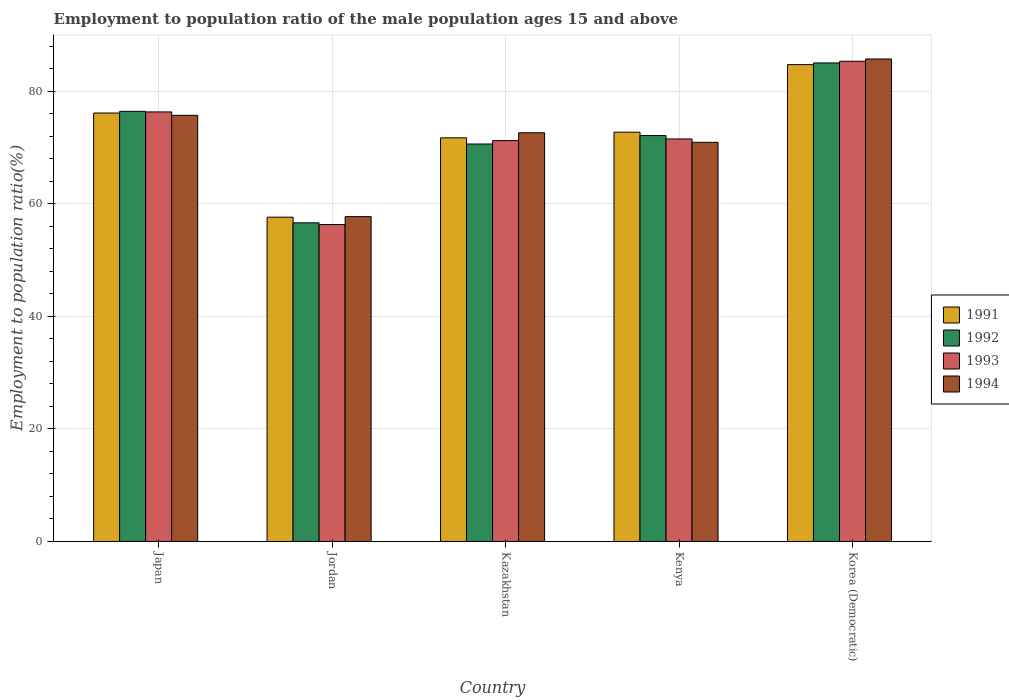How many different coloured bars are there?
Provide a short and direct response. 4. How many groups of bars are there?
Provide a short and direct response. 5. How many bars are there on the 2nd tick from the left?
Your response must be concise. 4. What is the label of the 5th group of bars from the left?
Ensure brevity in your answer.  Korea (Democratic). In how many cases, is the number of bars for a given country not equal to the number of legend labels?
Provide a short and direct response. 0. What is the employment to population ratio in 1994 in Kazakhstan?
Your response must be concise. 72.6. Across all countries, what is the maximum employment to population ratio in 1994?
Offer a terse response. 85.7. Across all countries, what is the minimum employment to population ratio in 1991?
Your answer should be compact. 57.6. In which country was the employment to population ratio in 1993 maximum?
Ensure brevity in your answer.  Korea (Democratic). In which country was the employment to population ratio in 1992 minimum?
Offer a terse response. Jordan. What is the total employment to population ratio in 1994 in the graph?
Provide a succinct answer. 362.6. What is the difference between the employment to population ratio in 1991 in Jordan and that in Kazakhstan?
Offer a very short reply. -14.1. What is the difference between the employment to population ratio in 1992 in Kenya and the employment to population ratio in 1993 in Jordan?
Offer a terse response. 15.8. What is the average employment to population ratio in 1994 per country?
Make the answer very short. 72.52. In how many countries, is the employment to population ratio in 1992 greater than 72 %?
Your answer should be compact. 3. What is the ratio of the employment to population ratio in 1994 in Kazakhstan to that in Korea (Democratic)?
Offer a terse response. 0.85. Is the difference between the employment to population ratio in 1994 in Jordan and Korea (Democratic) greater than the difference between the employment to population ratio in 1991 in Jordan and Korea (Democratic)?
Offer a very short reply. No. What is the difference between the highest and the second highest employment to population ratio in 1991?
Your answer should be very brief. -12. What is the difference between the highest and the lowest employment to population ratio in 1994?
Offer a very short reply. 28. In how many countries, is the employment to population ratio in 1993 greater than the average employment to population ratio in 1993 taken over all countries?
Ensure brevity in your answer.  2. Is it the case that in every country, the sum of the employment to population ratio in 1991 and employment to population ratio in 1993 is greater than the sum of employment to population ratio in 1994 and employment to population ratio in 1992?
Give a very brief answer. No. What does the 4th bar from the left in Japan represents?
Ensure brevity in your answer.  1994. What does the 4th bar from the right in Japan represents?
Give a very brief answer. 1991. Is it the case that in every country, the sum of the employment to population ratio in 1994 and employment to population ratio in 1993 is greater than the employment to population ratio in 1992?
Offer a terse response. Yes. How many bars are there?
Your response must be concise. 20. How many countries are there in the graph?
Offer a very short reply. 5. Are the values on the major ticks of Y-axis written in scientific E-notation?
Ensure brevity in your answer.  No. Does the graph contain any zero values?
Your answer should be compact. No. How many legend labels are there?
Offer a very short reply. 4. How are the legend labels stacked?
Provide a short and direct response. Vertical. What is the title of the graph?
Make the answer very short. Employment to population ratio of the male population ages 15 and above. Does "2004" appear as one of the legend labels in the graph?
Offer a very short reply. No. What is the label or title of the X-axis?
Provide a short and direct response. Country. What is the Employment to population ratio(%) in 1991 in Japan?
Provide a succinct answer. 76.1. What is the Employment to population ratio(%) in 1992 in Japan?
Give a very brief answer. 76.4. What is the Employment to population ratio(%) of 1993 in Japan?
Offer a terse response. 76.3. What is the Employment to population ratio(%) in 1994 in Japan?
Your answer should be very brief. 75.7. What is the Employment to population ratio(%) of 1991 in Jordan?
Your answer should be very brief. 57.6. What is the Employment to population ratio(%) of 1992 in Jordan?
Provide a short and direct response. 56.6. What is the Employment to population ratio(%) of 1993 in Jordan?
Your answer should be compact. 56.3. What is the Employment to population ratio(%) of 1994 in Jordan?
Offer a very short reply. 57.7. What is the Employment to population ratio(%) of 1991 in Kazakhstan?
Provide a succinct answer. 71.7. What is the Employment to population ratio(%) in 1992 in Kazakhstan?
Offer a terse response. 70.6. What is the Employment to population ratio(%) of 1993 in Kazakhstan?
Provide a succinct answer. 71.2. What is the Employment to population ratio(%) of 1994 in Kazakhstan?
Your response must be concise. 72.6. What is the Employment to population ratio(%) in 1991 in Kenya?
Keep it short and to the point. 72.7. What is the Employment to population ratio(%) of 1992 in Kenya?
Your answer should be very brief. 72.1. What is the Employment to population ratio(%) in 1993 in Kenya?
Provide a short and direct response. 71.5. What is the Employment to population ratio(%) in 1994 in Kenya?
Your response must be concise. 70.9. What is the Employment to population ratio(%) of 1991 in Korea (Democratic)?
Provide a succinct answer. 84.7. What is the Employment to population ratio(%) in 1993 in Korea (Democratic)?
Offer a very short reply. 85.3. What is the Employment to population ratio(%) in 1994 in Korea (Democratic)?
Provide a succinct answer. 85.7. Across all countries, what is the maximum Employment to population ratio(%) in 1991?
Make the answer very short. 84.7. Across all countries, what is the maximum Employment to population ratio(%) in 1993?
Provide a short and direct response. 85.3. Across all countries, what is the maximum Employment to population ratio(%) in 1994?
Provide a succinct answer. 85.7. Across all countries, what is the minimum Employment to population ratio(%) of 1991?
Make the answer very short. 57.6. Across all countries, what is the minimum Employment to population ratio(%) in 1992?
Keep it short and to the point. 56.6. Across all countries, what is the minimum Employment to population ratio(%) in 1993?
Your response must be concise. 56.3. Across all countries, what is the minimum Employment to population ratio(%) of 1994?
Ensure brevity in your answer.  57.7. What is the total Employment to population ratio(%) in 1991 in the graph?
Offer a very short reply. 362.8. What is the total Employment to population ratio(%) of 1992 in the graph?
Provide a short and direct response. 360.7. What is the total Employment to population ratio(%) in 1993 in the graph?
Keep it short and to the point. 360.6. What is the total Employment to population ratio(%) of 1994 in the graph?
Provide a short and direct response. 362.6. What is the difference between the Employment to population ratio(%) of 1992 in Japan and that in Jordan?
Make the answer very short. 19.8. What is the difference between the Employment to population ratio(%) of 1992 in Japan and that in Kazakhstan?
Your answer should be compact. 5.8. What is the difference between the Employment to population ratio(%) in 1991 in Japan and that in Kenya?
Your response must be concise. 3.4. What is the difference between the Employment to population ratio(%) of 1992 in Japan and that in Kenya?
Make the answer very short. 4.3. What is the difference between the Employment to population ratio(%) in 1993 in Japan and that in Kenya?
Make the answer very short. 4.8. What is the difference between the Employment to population ratio(%) of 1994 in Japan and that in Kenya?
Ensure brevity in your answer.  4.8. What is the difference between the Employment to population ratio(%) in 1993 in Japan and that in Korea (Democratic)?
Keep it short and to the point. -9. What is the difference between the Employment to population ratio(%) in 1991 in Jordan and that in Kazakhstan?
Keep it short and to the point. -14.1. What is the difference between the Employment to population ratio(%) in 1992 in Jordan and that in Kazakhstan?
Your answer should be very brief. -14. What is the difference between the Employment to population ratio(%) of 1993 in Jordan and that in Kazakhstan?
Offer a very short reply. -14.9. What is the difference between the Employment to population ratio(%) of 1994 in Jordan and that in Kazakhstan?
Your answer should be compact. -14.9. What is the difference between the Employment to population ratio(%) in 1991 in Jordan and that in Kenya?
Offer a terse response. -15.1. What is the difference between the Employment to population ratio(%) of 1992 in Jordan and that in Kenya?
Provide a succinct answer. -15.5. What is the difference between the Employment to population ratio(%) of 1993 in Jordan and that in Kenya?
Provide a short and direct response. -15.2. What is the difference between the Employment to population ratio(%) of 1991 in Jordan and that in Korea (Democratic)?
Provide a short and direct response. -27.1. What is the difference between the Employment to population ratio(%) in 1992 in Jordan and that in Korea (Democratic)?
Make the answer very short. -28.4. What is the difference between the Employment to population ratio(%) in 1993 in Jordan and that in Korea (Democratic)?
Your answer should be very brief. -29. What is the difference between the Employment to population ratio(%) in 1994 in Jordan and that in Korea (Democratic)?
Make the answer very short. -28. What is the difference between the Employment to population ratio(%) of 1991 in Kazakhstan and that in Kenya?
Ensure brevity in your answer.  -1. What is the difference between the Employment to population ratio(%) of 1993 in Kazakhstan and that in Kenya?
Your response must be concise. -0.3. What is the difference between the Employment to population ratio(%) of 1991 in Kazakhstan and that in Korea (Democratic)?
Your response must be concise. -13. What is the difference between the Employment to population ratio(%) of 1992 in Kazakhstan and that in Korea (Democratic)?
Ensure brevity in your answer.  -14.4. What is the difference between the Employment to population ratio(%) in 1993 in Kazakhstan and that in Korea (Democratic)?
Give a very brief answer. -14.1. What is the difference between the Employment to population ratio(%) of 1994 in Kazakhstan and that in Korea (Democratic)?
Keep it short and to the point. -13.1. What is the difference between the Employment to population ratio(%) in 1991 in Kenya and that in Korea (Democratic)?
Ensure brevity in your answer.  -12. What is the difference between the Employment to population ratio(%) of 1992 in Kenya and that in Korea (Democratic)?
Your answer should be very brief. -12.9. What is the difference between the Employment to population ratio(%) of 1994 in Kenya and that in Korea (Democratic)?
Offer a very short reply. -14.8. What is the difference between the Employment to population ratio(%) in 1991 in Japan and the Employment to population ratio(%) in 1993 in Jordan?
Provide a succinct answer. 19.8. What is the difference between the Employment to population ratio(%) of 1992 in Japan and the Employment to population ratio(%) of 1993 in Jordan?
Make the answer very short. 20.1. What is the difference between the Employment to population ratio(%) in 1991 in Japan and the Employment to population ratio(%) in 1992 in Kazakhstan?
Make the answer very short. 5.5. What is the difference between the Employment to population ratio(%) of 1991 in Japan and the Employment to population ratio(%) of 1993 in Kazakhstan?
Your answer should be compact. 4.9. What is the difference between the Employment to population ratio(%) of 1991 in Japan and the Employment to population ratio(%) of 1994 in Kazakhstan?
Your response must be concise. 3.5. What is the difference between the Employment to population ratio(%) of 1992 in Japan and the Employment to population ratio(%) of 1994 in Kazakhstan?
Keep it short and to the point. 3.8. What is the difference between the Employment to population ratio(%) in 1992 in Japan and the Employment to population ratio(%) in 1994 in Kenya?
Make the answer very short. 5.5. What is the difference between the Employment to population ratio(%) of 1993 in Japan and the Employment to population ratio(%) of 1994 in Kenya?
Your response must be concise. 5.4. What is the difference between the Employment to population ratio(%) of 1991 in Japan and the Employment to population ratio(%) of 1992 in Korea (Democratic)?
Keep it short and to the point. -8.9. What is the difference between the Employment to population ratio(%) in 1991 in Japan and the Employment to population ratio(%) in 1994 in Korea (Democratic)?
Your response must be concise. -9.6. What is the difference between the Employment to population ratio(%) of 1992 in Japan and the Employment to population ratio(%) of 1993 in Korea (Democratic)?
Provide a short and direct response. -8.9. What is the difference between the Employment to population ratio(%) in 1993 in Japan and the Employment to population ratio(%) in 1994 in Korea (Democratic)?
Keep it short and to the point. -9.4. What is the difference between the Employment to population ratio(%) in 1991 in Jordan and the Employment to population ratio(%) in 1992 in Kazakhstan?
Your answer should be compact. -13. What is the difference between the Employment to population ratio(%) in 1991 in Jordan and the Employment to population ratio(%) in 1993 in Kazakhstan?
Keep it short and to the point. -13.6. What is the difference between the Employment to population ratio(%) of 1991 in Jordan and the Employment to population ratio(%) of 1994 in Kazakhstan?
Offer a very short reply. -15. What is the difference between the Employment to population ratio(%) in 1992 in Jordan and the Employment to population ratio(%) in 1993 in Kazakhstan?
Offer a terse response. -14.6. What is the difference between the Employment to population ratio(%) in 1992 in Jordan and the Employment to population ratio(%) in 1994 in Kazakhstan?
Provide a short and direct response. -16. What is the difference between the Employment to population ratio(%) in 1993 in Jordan and the Employment to population ratio(%) in 1994 in Kazakhstan?
Your response must be concise. -16.3. What is the difference between the Employment to population ratio(%) of 1991 in Jordan and the Employment to population ratio(%) of 1992 in Kenya?
Provide a succinct answer. -14.5. What is the difference between the Employment to population ratio(%) of 1991 in Jordan and the Employment to population ratio(%) of 1993 in Kenya?
Provide a succinct answer. -13.9. What is the difference between the Employment to population ratio(%) of 1992 in Jordan and the Employment to population ratio(%) of 1993 in Kenya?
Provide a short and direct response. -14.9. What is the difference between the Employment to population ratio(%) of 1992 in Jordan and the Employment to population ratio(%) of 1994 in Kenya?
Keep it short and to the point. -14.3. What is the difference between the Employment to population ratio(%) of 1993 in Jordan and the Employment to population ratio(%) of 1994 in Kenya?
Keep it short and to the point. -14.6. What is the difference between the Employment to population ratio(%) in 1991 in Jordan and the Employment to population ratio(%) in 1992 in Korea (Democratic)?
Provide a short and direct response. -27.4. What is the difference between the Employment to population ratio(%) of 1991 in Jordan and the Employment to population ratio(%) of 1993 in Korea (Democratic)?
Your answer should be very brief. -27.7. What is the difference between the Employment to population ratio(%) of 1991 in Jordan and the Employment to population ratio(%) of 1994 in Korea (Democratic)?
Your answer should be very brief. -28.1. What is the difference between the Employment to population ratio(%) of 1992 in Jordan and the Employment to population ratio(%) of 1993 in Korea (Democratic)?
Offer a terse response. -28.7. What is the difference between the Employment to population ratio(%) in 1992 in Jordan and the Employment to population ratio(%) in 1994 in Korea (Democratic)?
Give a very brief answer. -29.1. What is the difference between the Employment to population ratio(%) of 1993 in Jordan and the Employment to population ratio(%) of 1994 in Korea (Democratic)?
Make the answer very short. -29.4. What is the difference between the Employment to population ratio(%) in 1993 in Kazakhstan and the Employment to population ratio(%) in 1994 in Kenya?
Offer a very short reply. 0.3. What is the difference between the Employment to population ratio(%) in 1992 in Kazakhstan and the Employment to population ratio(%) in 1993 in Korea (Democratic)?
Provide a short and direct response. -14.7. What is the difference between the Employment to population ratio(%) in 1992 in Kazakhstan and the Employment to population ratio(%) in 1994 in Korea (Democratic)?
Your answer should be very brief. -15.1. What is the difference between the Employment to population ratio(%) in 1993 in Kazakhstan and the Employment to population ratio(%) in 1994 in Korea (Democratic)?
Keep it short and to the point. -14.5. What is the difference between the Employment to population ratio(%) in 1991 in Kenya and the Employment to population ratio(%) in 1993 in Korea (Democratic)?
Make the answer very short. -12.6. What is the difference between the Employment to population ratio(%) in 1991 in Kenya and the Employment to population ratio(%) in 1994 in Korea (Democratic)?
Keep it short and to the point. -13. What is the difference between the Employment to population ratio(%) in 1992 in Kenya and the Employment to population ratio(%) in 1993 in Korea (Democratic)?
Offer a very short reply. -13.2. What is the difference between the Employment to population ratio(%) of 1993 in Kenya and the Employment to population ratio(%) of 1994 in Korea (Democratic)?
Ensure brevity in your answer.  -14.2. What is the average Employment to population ratio(%) in 1991 per country?
Your answer should be very brief. 72.56. What is the average Employment to population ratio(%) of 1992 per country?
Offer a terse response. 72.14. What is the average Employment to population ratio(%) in 1993 per country?
Offer a terse response. 72.12. What is the average Employment to population ratio(%) of 1994 per country?
Give a very brief answer. 72.52. What is the difference between the Employment to population ratio(%) in 1991 and Employment to population ratio(%) in 1992 in Japan?
Your answer should be very brief. -0.3. What is the difference between the Employment to population ratio(%) of 1991 and Employment to population ratio(%) of 1993 in Japan?
Your answer should be very brief. -0.2. What is the difference between the Employment to population ratio(%) in 1992 and Employment to population ratio(%) in 1993 in Japan?
Offer a terse response. 0.1. What is the difference between the Employment to population ratio(%) in 1992 and Employment to population ratio(%) in 1994 in Japan?
Ensure brevity in your answer.  0.7. What is the difference between the Employment to population ratio(%) of 1991 and Employment to population ratio(%) of 1993 in Jordan?
Make the answer very short. 1.3. What is the difference between the Employment to population ratio(%) of 1992 and Employment to population ratio(%) of 1994 in Jordan?
Give a very brief answer. -1.1. What is the difference between the Employment to population ratio(%) of 1991 and Employment to population ratio(%) of 1993 in Kazakhstan?
Make the answer very short. 0.5. What is the difference between the Employment to population ratio(%) in 1991 and Employment to population ratio(%) in 1994 in Kazakhstan?
Your response must be concise. -0.9. What is the difference between the Employment to population ratio(%) of 1992 and Employment to population ratio(%) of 1993 in Kazakhstan?
Your response must be concise. -0.6. What is the difference between the Employment to population ratio(%) in 1991 and Employment to population ratio(%) in 1992 in Kenya?
Give a very brief answer. 0.6. What is the difference between the Employment to population ratio(%) in 1991 and Employment to population ratio(%) in 1993 in Kenya?
Make the answer very short. 1.2. What is the difference between the Employment to population ratio(%) in 1991 and Employment to population ratio(%) in 1994 in Kenya?
Keep it short and to the point. 1.8. What is the difference between the Employment to population ratio(%) in 1992 and Employment to population ratio(%) in 1994 in Kenya?
Offer a very short reply. 1.2. What is the difference between the Employment to population ratio(%) in 1991 and Employment to population ratio(%) in 1993 in Korea (Democratic)?
Your answer should be very brief. -0.6. What is the difference between the Employment to population ratio(%) in 1992 and Employment to population ratio(%) in 1994 in Korea (Democratic)?
Your answer should be compact. -0.7. What is the difference between the Employment to population ratio(%) of 1993 and Employment to population ratio(%) of 1994 in Korea (Democratic)?
Give a very brief answer. -0.4. What is the ratio of the Employment to population ratio(%) in 1991 in Japan to that in Jordan?
Your answer should be very brief. 1.32. What is the ratio of the Employment to population ratio(%) in 1992 in Japan to that in Jordan?
Ensure brevity in your answer.  1.35. What is the ratio of the Employment to population ratio(%) in 1993 in Japan to that in Jordan?
Give a very brief answer. 1.36. What is the ratio of the Employment to population ratio(%) of 1994 in Japan to that in Jordan?
Offer a terse response. 1.31. What is the ratio of the Employment to population ratio(%) in 1991 in Japan to that in Kazakhstan?
Offer a very short reply. 1.06. What is the ratio of the Employment to population ratio(%) in 1992 in Japan to that in Kazakhstan?
Provide a succinct answer. 1.08. What is the ratio of the Employment to population ratio(%) in 1993 in Japan to that in Kazakhstan?
Provide a succinct answer. 1.07. What is the ratio of the Employment to population ratio(%) in 1994 in Japan to that in Kazakhstan?
Provide a succinct answer. 1.04. What is the ratio of the Employment to population ratio(%) of 1991 in Japan to that in Kenya?
Ensure brevity in your answer.  1.05. What is the ratio of the Employment to population ratio(%) of 1992 in Japan to that in Kenya?
Your response must be concise. 1.06. What is the ratio of the Employment to population ratio(%) in 1993 in Japan to that in Kenya?
Offer a terse response. 1.07. What is the ratio of the Employment to population ratio(%) in 1994 in Japan to that in Kenya?
Give a very brief answer. 1.07. What is the ratio of the Employment to population ratio(%) in 1991 in Japan to that in Korea (Democratic)?
Provide a succinct answer. 0.9. What is the ratio of the Employment to population ratio(%) of 1992 in Japan to that in Korea (Democratic)?
Ensure brevity in your answer.  0.9. What is the ratio of the Employment to population ratio(%) in 1993 in Japan to that in Korea (Democratic)?
Your answer should be very brief. 0.89. What is the ratio of the Employment to population ratio(%) of 1994 in Japan to that in Korea (Democratic)?
Your answer should be compact. 0.88. What is the ratio of the Employment to population ratio(%) in 1991 in Jordan to that in Kazakhstan?
Make the answer very short. 0.8. What is the ratio of the Employment to population ratio(%) of 1992 in Jordan to that in Kazakhstan?
Give a very brief answer. 0.8. What is the ratio of the Employment to population ratio(%) of 1993 in Jordan to that in Kazakhstan?
Give a very brief answer. 0.79. What is the ratio of the Employment to population ratio(%) in 1994 in Jordan to that in Kazakhstan?
Keep it short and to the point. 0.79. What is the ratio of the Employment to population ratio(%) of 1991 in Jordan to that in Kenya?
Keep it short and to the point. 0.79. What is the ratio of the Employment to population ratio(%) of 1992 in Jordan to that in Kenya?
Your answer should be very brief. 0.79. What is the ratio of the Employment to population ratio(%) of 1993 in Jordan to that in Kenya?
Make the answer very short. 0.79. What is the ratio of the Employment to population ratio(%) of 1994 in Jordan to that in Kenya?
Offer a very short reply. 0.81. What is the ratio of the Employment to population ratio(%) of 1991 in Jordan to that in Korea (Democratic)?
Keep it short and to the point. 0.68. What is the ratio of the Employment to population ratio(%) in 1992 in Jordan to that in Korea (Democratic)?
Your response must be concise. 0.67. What is the ratio of the Employment to population ratio(%) in 1993 in Jordan to that in Korea (Democratic)?
Your answer should be very brief. 0.66. What is the ratio of the Employment to population ratio(%) in 1994 in Jordan to that in Korea (Democratic)?
Provide a short and direct response. 0.67. What is the ratio of the Employment to population ratio(%) of 1991 in Kazakhstan to that in Kenya?
Make the answer very short. 0.99. What is the ratio of the Employment to population ratio(%) of 1992 in Kazakhstan to that in Kenya?
Offer a very short reply. 0.98. What is the ratio of the Employment to population ratio(%) of 1994 in Kazakhstan to that in Kenya?
Provide a short and direct response. 1.02. What is the ratio of the Employment to population ratio(%) in 1991 in Kazakhstan to that in Korea (Democratic)?
Your answer should be compact. 0.85. What is the ratio of the Employment to population ratio(%) of 1992 in Kazakhstan to that in Korea (Democratic)?
Offer a very short reply. 0.83. What is the ratio of the Employment to population ratio(%) in 1993 in Kazakhstan to that in Korea (Democratic)?
Your answer should be compact. 0.83. What is the ratio of the Employment to population ratio(%) of 1994 in Kazakhstan to that in Korea (Democratic)?
Offer a very short reply. 0.85. What is the ratio of the Employment to population ratio(%) in 1991 in Kenya to that in Korea (Democratic)?
Offer a very short reply. 0.86. What is the ratio of the Employment to population ratio(%) of 1992 in Kenya to that in Korea (Democratic)?
Offer a very short reply. 0.85. What is the ratio of the Employment to population ratio(%) of 1993 in Kenya to that in Korea (Democratic)?
Your answer should be very brief. 0.84. What is the ratio of the Employment to population ratio(%) in 1994 in Kenya to that in Korea (Democratic)?
Give a very brief answer. 0.83. What is the difference between the highest and the second highest Employment to population ratio(%) of 1991?
Your response must be concise. 8.6. What is the difference between the highest and the second highest Employment to population ratio(%) in 1994?
Give a very brief answer. 10. What is the difference between the highest and the lowest Employment to population ratio(%) in 1991?
Make the answer very short. 27.1. What is the difference between the highest and the lowest Employment to population ratio(%) of 1992?
Provide a succinct answer. 28.4. What is the difference between the highest and the lowest Employment to population ratio(%) of 1994?
Your response must be concise. 28. 